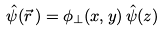<formula> <loc_0><loc_0><loc_500><loc_500>\hat { \psi } ( \vec { r } \, ) = \phi _ { \perp } ( x , y ) \, \hat { \psi } ( z )</formula> 